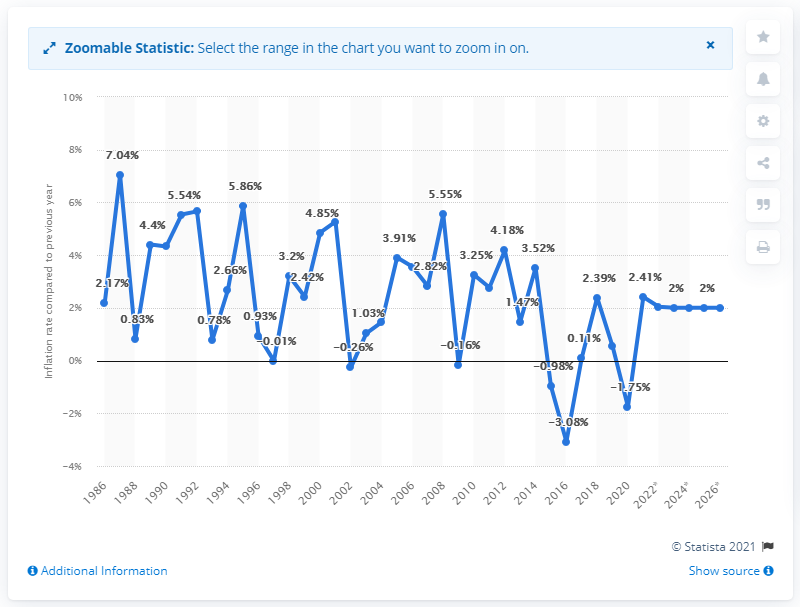Highlight a few significant elements in this photo. In 2018, the inflation rate in Saint Lucia was 2.41%. 